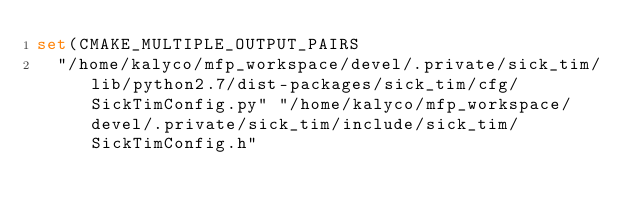<code> <loc_0><loc_0><loc_500><loc_500><_CMake_>set(CMAKE_MULTIPLE_OUTPUT_PAIRS
  "/home/kalyco/mfp_workspace/devel/.private/sick_tim/lib/python2.7/dist-packages/sick_tim/cfg/SickTimConfig.py" "/home/kalyco/mfp_workspace/devel/.private/sick_tim/include/sick_tim/SickTimConfig.h"</code> 